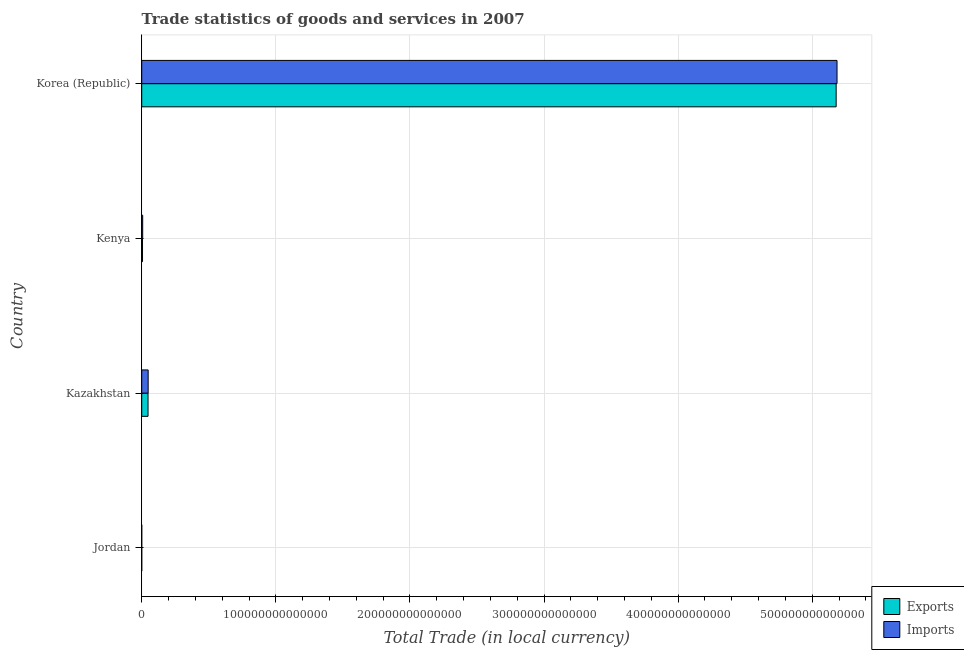How many different coloured bars are there?
Provide a short and direct response. 2. How many groups of bars are there?
Ensure brevity in your answer.  4. How many bars are there on the 2nd tick from the bottom?
Offer a terse response. 2. What is the label of the 4th group of bars from the top?
Your answer should be very brief. Jordan. In how many cases, is the number of bars for a given country not equal to the number of legend labels?
Ensure brevity in your answer.  0. What is the imports of goods and services in Kazakhstan?
Offer a very short reply. 4.80e+12. Across all countries, what is the maximum imports of goods and services?
Give a very brief answer. 5.18e+14. Across all countries, what is the minimum imports of goods and services?
Your answer should be very brief. 5.74e+09. In which country was the imports of goods and services maximum?
Your answer should be very brief. Korea (Republic). In which country was the imports of goods and services minimum?
Provide a succinct answer. Jordan. What is the total imports of goods and services in the graph?
Offer a very short reply. 5.24e+14. What is the difference between the imports of goods and services in Jordan and that in Kenya?
Make the answer very short. -7.17e+11. What is the difference between the export of goods and services in Kenya and the imports of goods and services in Kazakhstan?
Offer a terse response. -4.21e+12. What is the average export of goods and services per country?
Offer a terse response. 1.31e+14. What is the difference between the export of goods and services and imports of goods and services in Kenya?
Offer a very short reply. -1.32e+11. What is the ratio of the imports of goods and services in Jordan to that in Korea (Republic)?
Offer a very short reply. 0. Is the export of goods and services in Jordan less than that in Korea (Republic)?
Offer a very short reply. Yes. What is the difference between the highest and the second highest export of goods and services?
Keep it short and to the point. 5.13e+14. What is the difference between the highest and the lowest imports of goods and services?
Give a very brief answer. 5.18e+14. In how many countries, is the imports of goods and services greater than the average imports of goods and services taken over all countries?
Give a very brief answer. 1. Is the sum of the imports of goods and services in Jordan and Kenya greater than the maximum export of goods and services across all countries?
Your answer should be compact. No. What does the 1st bar from the top in Korea (Republic) represents?
Offer a very short reply. Imports. What does the 1st bar from the bottom in Korea (Republic) represents?
Provide a succinct answer. Exports. What is the difference between two consecutive major ticks on the X-axis?
Offer a very short reply. 1.00e+14. Does the graph contain any zero values?
Provide a short and direct response. No. Does the graph contain grids?
Offer a very short reply. Yes. How many legend labels are there?
Ensure brevity in your answer.  2. How are the legend labels stacked?
Ensure brevity in your answer.  Vertical. What is the title of the graph?
Your response must be concise. Trade statistics of goods and services in 2007. Does "Number of departures" appear as one of the legend labels in the graph?
Your answer should be very brief. No. What is the label or title of the X-axis?
Offer a terse response. Total Trade (in local currency). What is the Total Trade (in local currency) in Exports in Jordan?
Your answer should be very brief. 4.10e+09. What is the Total Trade (in local currency) in Imports in Jordan?
Provide a succinct answer. 5.74e+09. What is the Total Trade (in local currency) in Exports in Kazakhstan?
Provide a succinct answer. 4.70e+12. What is the Total Trade (in local currency) in Imports in Kazakhstan?
Make the answer very short. 4.80e+12. What is the Total Trade (in local currency) in Exports in Kenya?
Make the answer very short. 5.91e+11. What is the Total Trade (in local currency) in Imports in Kenya?
Provide a succinct answer. 7.23e+11. What is the Total Trade (in local currency) of Exports in Korea (Republic)?
Keep it short and to the point. 5.18e+14. What is the Total Trade (in local currency) of Imports in Korea (Republic)?
Keep it short and to the point. 5.18e+14. Across all countries, what is the maximum Total Trade (in local currency) of Exports?
Provide a short and direct response. 5.18e+14. Across all countries, what is the maximum Total Trade (in local currency) in Imports?
Offer a terse response. 5.18e+14. Across all countries, what is the minimum Total Trade (in local currency) of Exports?
Offer a very short reply. 4.10e+09. Across all countries, what is the minimum Total Trade (in local currency) in Imports?
Your response must be concise. 5.74e+09. What is the total Total Trade (in local currency) in Exports in the graph?
Ensure brevity in your answer.  5.23e+14. What is the total Total Trade (in local currency) of Imports in the graph?
Provide a succinct answer. 5.24e+14. What is the difference between the Total Trade (in local currency) in Exports in Jordan and that in Kazakhstan?
Your response must be concise. -4.70e+12. What is the difference between the Total Trade (in local currency) of Imports in Jordan and that in Kazakhstan?
Provide a short and direct response. -4.80e+12. What is the difference between the Total Trade (in local currency) of Exports in Jordan and that in Kenya?
Ensure brevity in your answer.  -5.87e+11. What is the difference between the Total Trade (in local currency) in Imports in Jordan and that in Kenya?
Your response must be concise. -7.17e+11. What is the difference between the Total Trade (in local currency) of Exports in Jordan and that in Korea (Republic)?
Provide a succinct answer. -5.18e+14. What is the difference between the Total Trade (in local currency) of Imports in Jordan and that in Korea (Republic)?
Your answer should be very brief. -5.18e+14. What is the difference between the Total Trade (in local currency) in Exports in Kazakhstan and that in Kenya?
Your response must be concise. 4.11e+12. What is the difference between the Total Trade (in local currency) of Imports in Kazakhstan and that in Kenya?
Your response must be concise. 4.08e+12. What is the difference between the Total Trade (in local currency) in Exports in Kazakhstan and that in Korea (Republic)?
Offer a terse response. -5.13e+14. What is the difference between the Total Trade (in local currency) in Imports in Kazakhstan and that in Korea (Republic)?
Offer a very short reply. -5.14e+14. What is the difference between the Total Trade (in local currency) of Exports in Kenya and that in Korea (Republic)?
Make the answer very short. -5.17e+14. What is the difference between the Total Trade (in local currency) of Imports in Kenya and that in Korea (Republic)?
Your answer should be very brief. -5.18e+14. What is the difference between the Total Trade (in local currency) of Exports in Jordan and the Total Trade (in local currency) of Imports in Kazakhstan?
Make the answer very short. -4.80e+12. What is the difference between the Total Trade (in local currency) in Exports in Jordan and the Total Trade (in local currency) in Imports in Kenya?
Your response must be concise. -7.19e+11. What is the difference between the Total Trade (in local currency) of Exports in Jordan and the Total Trade (in local currency) of Imports in Korea (Republic)?
Ensure brevity in your answer.  -5.18e+14. What is the difference between the Total Trade (in local currency) of Exports in Kazakhstan and the Total Trade (in local currency) of Imports in Kenya?
Provide a short and direct response. 3.98e+12. What is the difference between the Total Trade (in local currency) of Exports in Kazakhstan and the Total Trade (in local currency) of Imports in Korea (Republic)?
Provide a short and direct response. -5.14e+14. What is the difference between the Total Trade (in local currency) in Exports in Kenya and the Total Trade (in local currency) in Imports in Korea (Republic)?
Make the answer very short. -5.18e+14. What is the average Total Trade (in local currency) of Exports per country?
Offer a very short reply. 1.31e+14. What is the average Total Trade (in local currency) of Imports per country?
Provide a short and direct response. 1.31e+14. What is the difference between the Total Trade (in local currency) of Exports and Total Trade (in local currency) of Imports in Jordan?
Give a very brief answer. -1.64e+09. What is the difference between the Total Trade (in local currency) of Exports and Total Trade (in local currency) of Imports in Kazakhstan?
Offer a terse response. -9.87e+1. What is the difference between the Total Trade (in local currency) of Exports and Total Trade (in local currency) of Imports in Kenya?
Your answer should be compact. -1.32e+11. What is the difference between the Total Trade (in local currency) of Exports and Total Trade (in local currency) of Imports in Korea (Republic)?
Your answer should be very brief. -6.50e+11. What is the ratio of the Total Trade (in local currency) of Exports in Jordan to that in Kazakhstan?
Offer a terse response. 0. What is the ratio of the Total Trade (in local currency) in Imports in Jordan to that in Kazakhstan?
Provide a short and direct response. 0. What is the ratio of the Total Trade (in local currency) of Exports in Jordan to that in Kenya?
Keep it short and to the point. 0.01. What is the ratio of the Total Trade (in local currency) of Imports in Jordan to that in Kenya?
Provide a succinct answer. 0.01. What is the ratio of the Total Trade (in local currency) of Exports in Kazakhstan to that in Kenya?
Offer a very short reply. 7.96. What is the ratio of the Total Trade (in local currency) of Imports in Kazakhstan to that in Kenya?
Your response must be concise. 6.65. What is the ratio of the Total Trade (in local currency) of Exports in Kazakhstan to that in Korea (Republic)?
Your answer should be compact. 0.01. What is the ratio of the Total Trade (in local currency) in Imports in Kazakhstan to that in Korea (Republic)?
Ensure brevity in your answer.  0.01. What is the ratio of the Total Trade (in local currency) of Exports in Kenya to that in Korea (Republic)?
Your answer should be compact. 0. What is the ratio of the Total Trade (in local currency) of Imports in Kenya to that in Korea (Republic)?
Keep it short and to the point. 0. What is the difference between the highest and the second highest Total Trade (in local currency) of Exports?
Provide a succinct answer. 5.13e+14. What is the difference between the highest and the second highest Total Trade (in local currency) in Imports?
Your answer should be compact. 5.14e+14. What is the difference between the highest and the lowest Total Trade (in local currency) in Exports?
Your answer should be very brief. 5.18e+14. What is the difference between the highest and the lowest Total Trade (in local currency) of Imports?
Your response must be concise. 5.18e+14. 